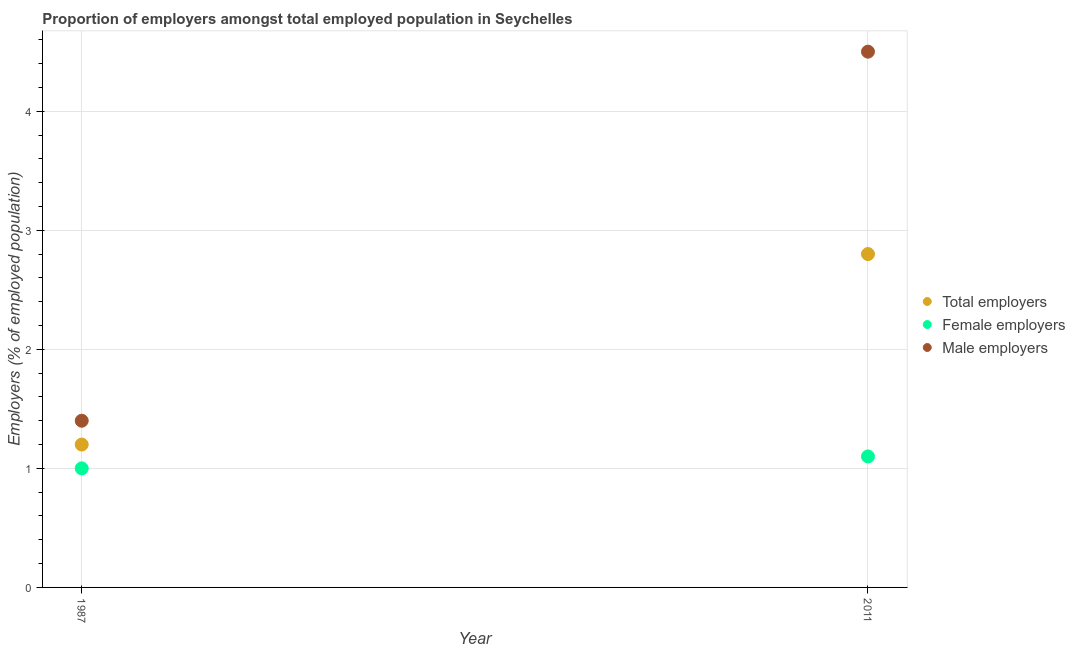Is the number of dotlines equal to the number of legend labels?
Provide a short and direct response. Yes. What is the percentage of total employers in 2011?
Your answer should be very brief. 2.8. Across all years, what is the maximum percentage of female employers?
Offer a very short reply. 1.1. Across all years, what is the minimum percentage of female employers?
Provide a succinct answer. 1. In which year was the percentage of male employers maximum?
Keep it short and to the point. 2011. What is the difference between the percentage of female employers in 1987 and that in 2011?
Your answer should be very brief. -0.1. What is the difference between the percentage of male employers in 2011 and the percentage of total employers in 1987?
Keep it short and to the point. 3.3. What is the average percentage of total employers per year?
Keep it short and to the point. 2. In the year 2011, what is the difference between the percentage of male employers and percentage of female employers?
Offer a very short reply. 3.4. What is the ratio of the percentage of male employers in 1987 to that in 2011?
Your answer should be compact. 0.31. Is the percentage of female employers in 1987 less than that in 2011?
Provide a short and direct response. Yes. In how many years, is the percentage of female employers greater than the average percentage of female employers taken over all years?
Keep it short and to the point. 1. Is it the case that in every year, the sum of the percentage of total employers and percentage of female employers is greater than the percentage of male employers?
Offer a terse response. No. How many years are there in the graph?
Keep it short and to the point. 2. Are the values on the major ticks of Y-axis written in scientific E-notation?
Provide a short and direct response. No. Does the graph contain any zero values?
Provide a succinct answer. No. Does the graph contain grids?
Provide a succinct answer. Yes. How many legend labels are there?
Provide a succinct answer. 3. What is the title of the graph?
Provide a short and direct response. Proportion of employers amongst total employed population in Seychelles. Does "Social insurance" appear as one of the legend labels in the graph?
Make the answer very short. No. What is the label or title of the X-axis?
Your answer should be compact. Year. What is the label or title of the Y-axis?
Your answer should be very brief. Employers (% of employed population). What is the Employers (% of employed population) of Total employers in 1987?
Provide a short and direct response. 1.2. What is the Employers (% of employed population) of Male employers in 1987?
Give a very brief answer. 1.4. What is the Employers (% of employed population) in Total employers in 2011?
Offer a very short reply. 2.8. What is the Employers (% of employed population) in Female employers in 2011?
Make the answer very short. 1.1. What is the Employers (% of employed population) of Male employers in 2011?
Your answer should be compact. 4.5. Across all years, what is the maximum Employers (% of employed population) of Total employers?
Provide a succinct answer. 2.8. Across all years, what is the maximum Employers (% of employed population) of Female employers?
Your response must be concise. 1.1. Across all years, what is the minimum Employers (% of employed population) in Total employers?
Keep it short and to the point. 1.2. Across all years, what is the minimum Employers (% of employed population) in Male employers?
Give a very brief answer. 1.4. What is the difference between the Employers (% of employed population) in Total employers in 1987 and that in 2011?
Offer a terse response. -1.6. What is the difference between the Employers (% of employed population) in Male employers in 1987 and that in 2011?
Provide a short and direct response. -3.1. What is the difference between the Employers (% of employed population) in Total employers in 1987 and the Employers (% of employed population) in Male employers in 2011?
Provide a short and direct response. -3.3. What is the difference between the Employers (% of employed population) in Female employers in 1987 and the Employers (% of employed population) in Male employers in 2011?
Your answer should be very brief. -3.5. What is the average Employers (% of employed population) in Total employers per year?
Give a very brief answer. 2. What is the average Employers (% of employed population) of Male employers per year?
Keep it short and to the point. 2.95. In the year 2011, what is the difference between the Employers (% of employed population) of Total employers and Employers (% of employed population) of Male employers?
Offer a very short reply. -1.7. In the year 2011, what is the difference between the Employers (% of employed population) in Female employers and Employers (% of employed population) in Male employers?
Offer a terse response. -3.4. What is the ratio of the Employers (% of employed population) in Total employers in 1987 to that in 2011?
Make the answer very short. 0.43. What is the ratio of the Employers (% of employed population) in Female employers in 1987 to that in 2011?
Provide a succinct answer. 0.91. What is the ratio of the Employers (% of employed population) in Male employers in 1987 to that in 2011?
Give a very brief answer. 0.31. What is the difference between the highest and the lowest Employers (% of employed population) of Total employers?
Make the answer very short. 1.6. What is the difference between the highest and the lowest Employers (% of employed population) in Female employers?
Provide a succinct answer. 0.1. 